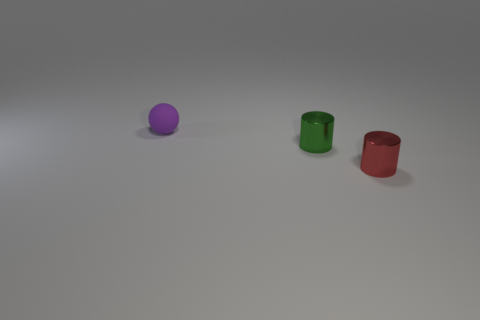Add 1 big gray metallic cubes. How many objects exist? 4 Subtract all spheres. How many objects are left? 2 Add 1 purple spheres. How many purple spheres are left? 2 Add 1 cylinders. How many cylinders exist? 3 Subtract 0 gray spheres. How many objects are left? 3 Subtract all purple spheres. Subtract all small red metal things. How many objects are left? 1 